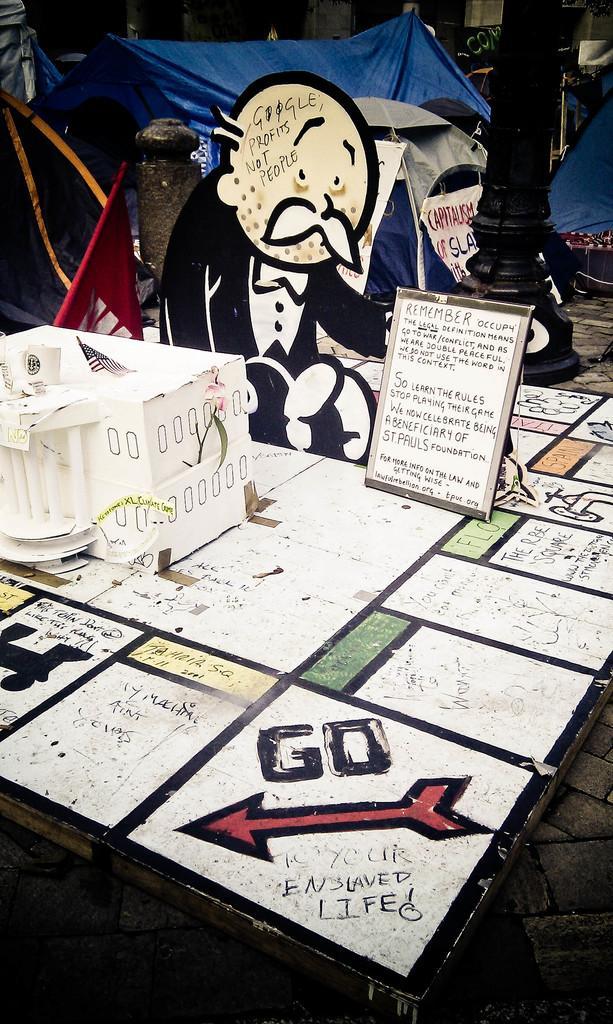Could you give a brief overview of what you see in this image? In this image, we can see a table with some painting and some text written on it. On the right side of the table, we can see a board with some text written on it. On the left side, we can table, we can see a box and a flag. In the background of the table, we can see a painting of a person sitting. In the background, we can also see huts, hoardings, pillar. 